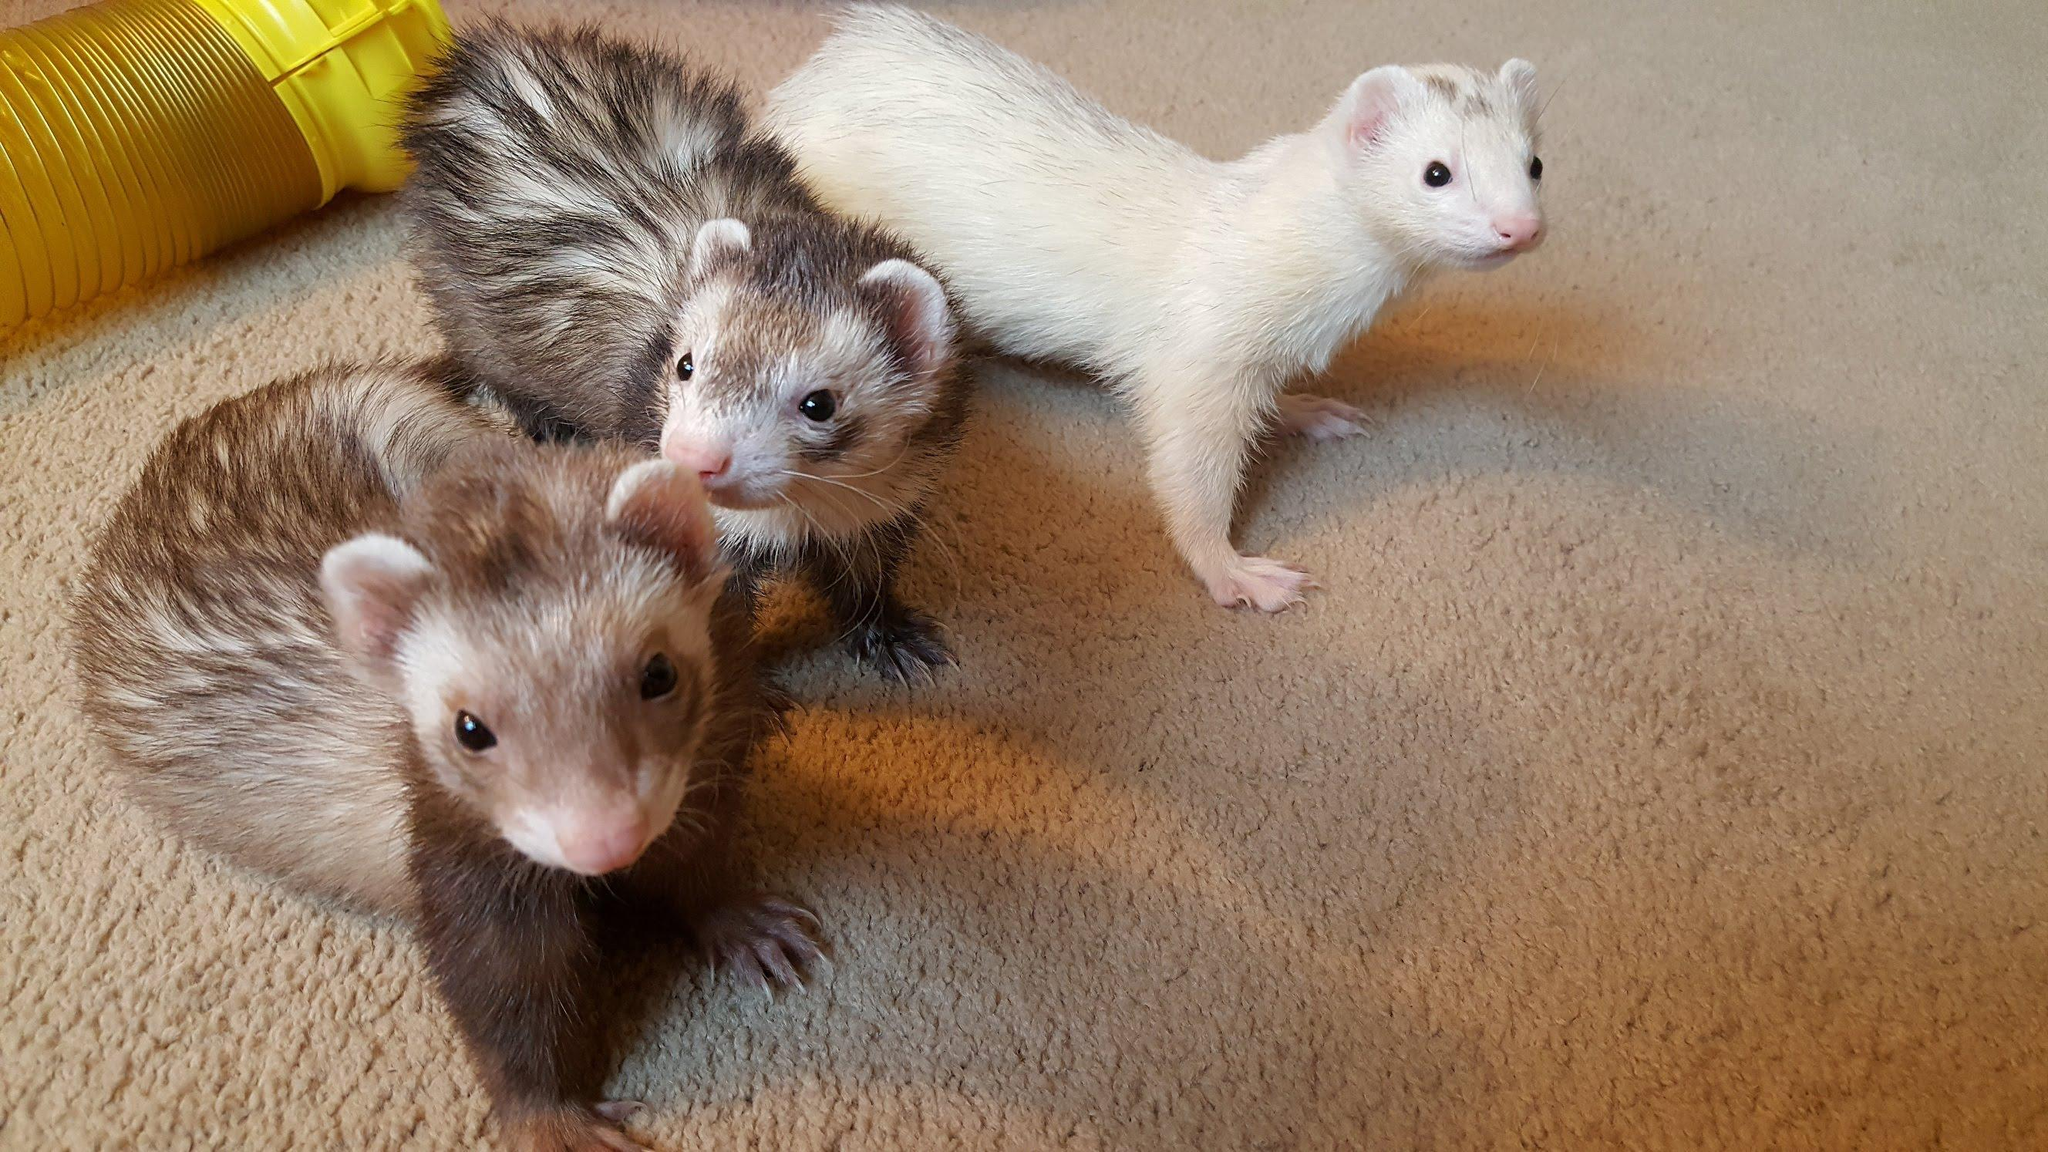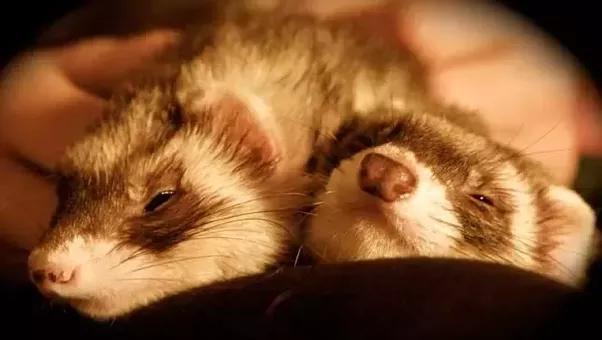The first image is the image on the left, the second image is the image on the right. Evaluate the accuracy of this statement regarding the images: "There are exactly two ferrets in both images.". Is it true? Answer yes or no. No. The first image is the image on the left, the second image is the image on the right. Examine the images to the left and right. Is the description "The left image includes at least one ferret standing on all fours, and the right image contains two side-by-side ferrets with at least one having sleepy eyes." accurate? Answer yes or no. Yes. 